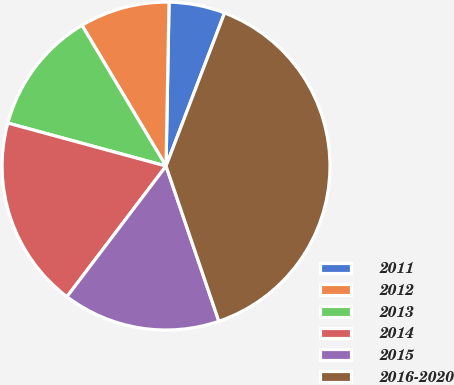<chart> <loc_0><loc_0><loc_500><loc_500><pie_chart><fcel>2011<fcel>2012<fcel>2013<fcel>2014<fcel>2015<fcel>2016-2020<nl><fcel>5.52%<fcel>8.86%<fcel>12.21%<fcel>18.9%<fcel>15.55%<fcel>38.97%<nl></chart> 